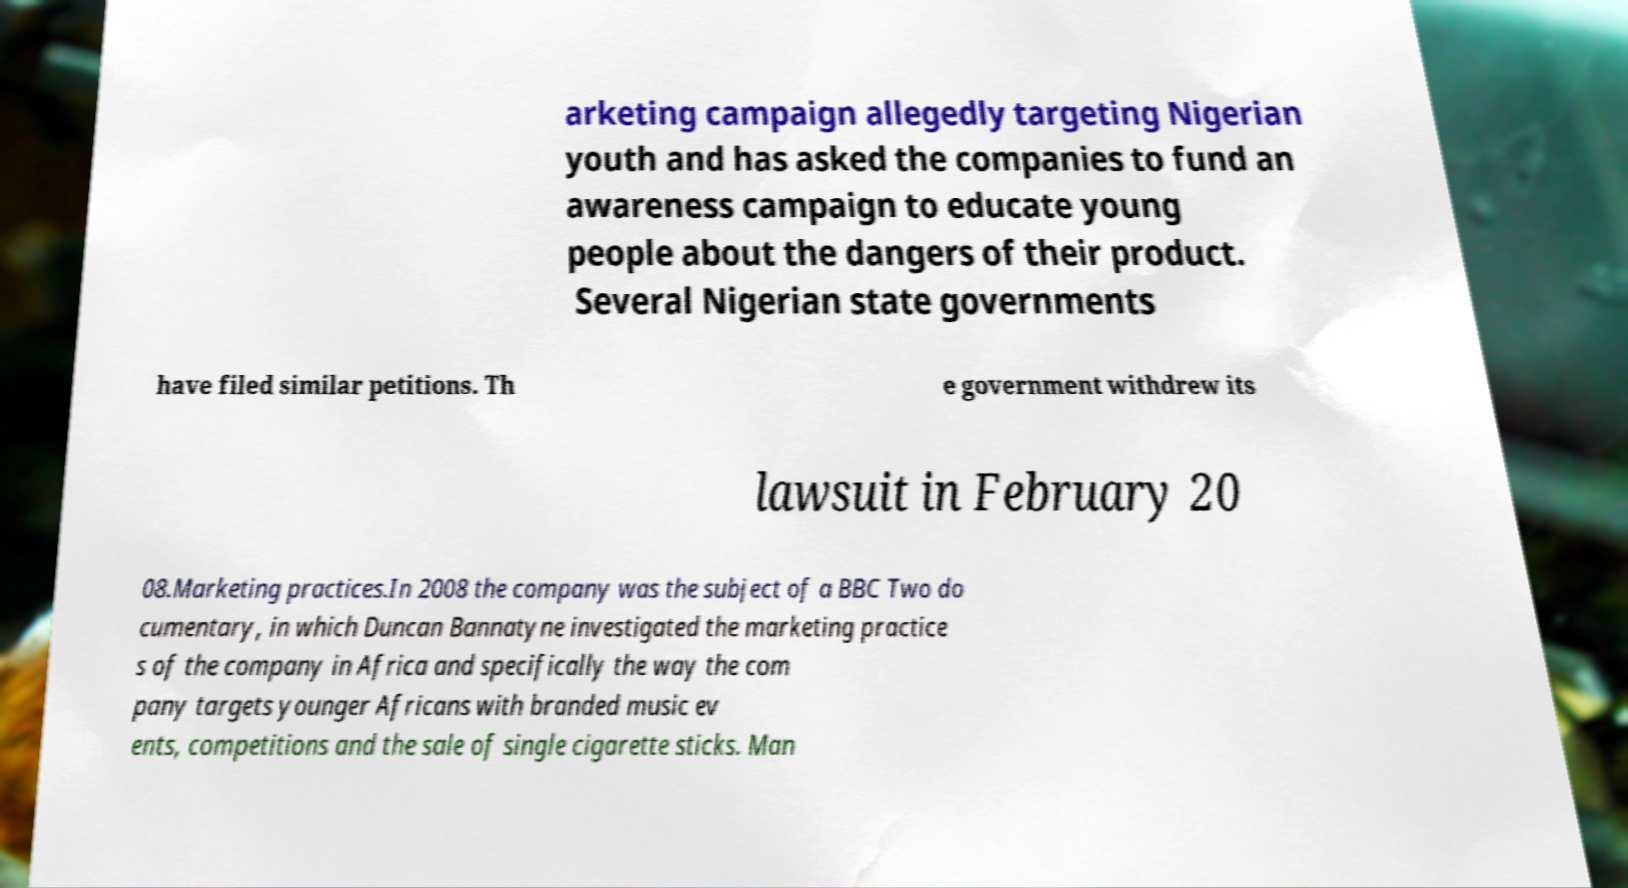What messages or text are displayed in this image? I need them in a readable, typed format. arketing campaign allegedly targeting Nigerian youth and has asked the companies to fund an awareness campaign to educate young people about the dangers of their product. Several Nigerian state governments have filed similar petitions. Th e government withdrew its lawsuit in February 20 08.Marketing practices.In 2008 the company was the subject of a BBC Two do cumentary, in which Duncan Bannatyne investigated the marketing practice s of the company in Africa and specifically the way the com pany targets younger Africans with branded music ev ents, competitions and the sale of single cigarette sticks. Man 